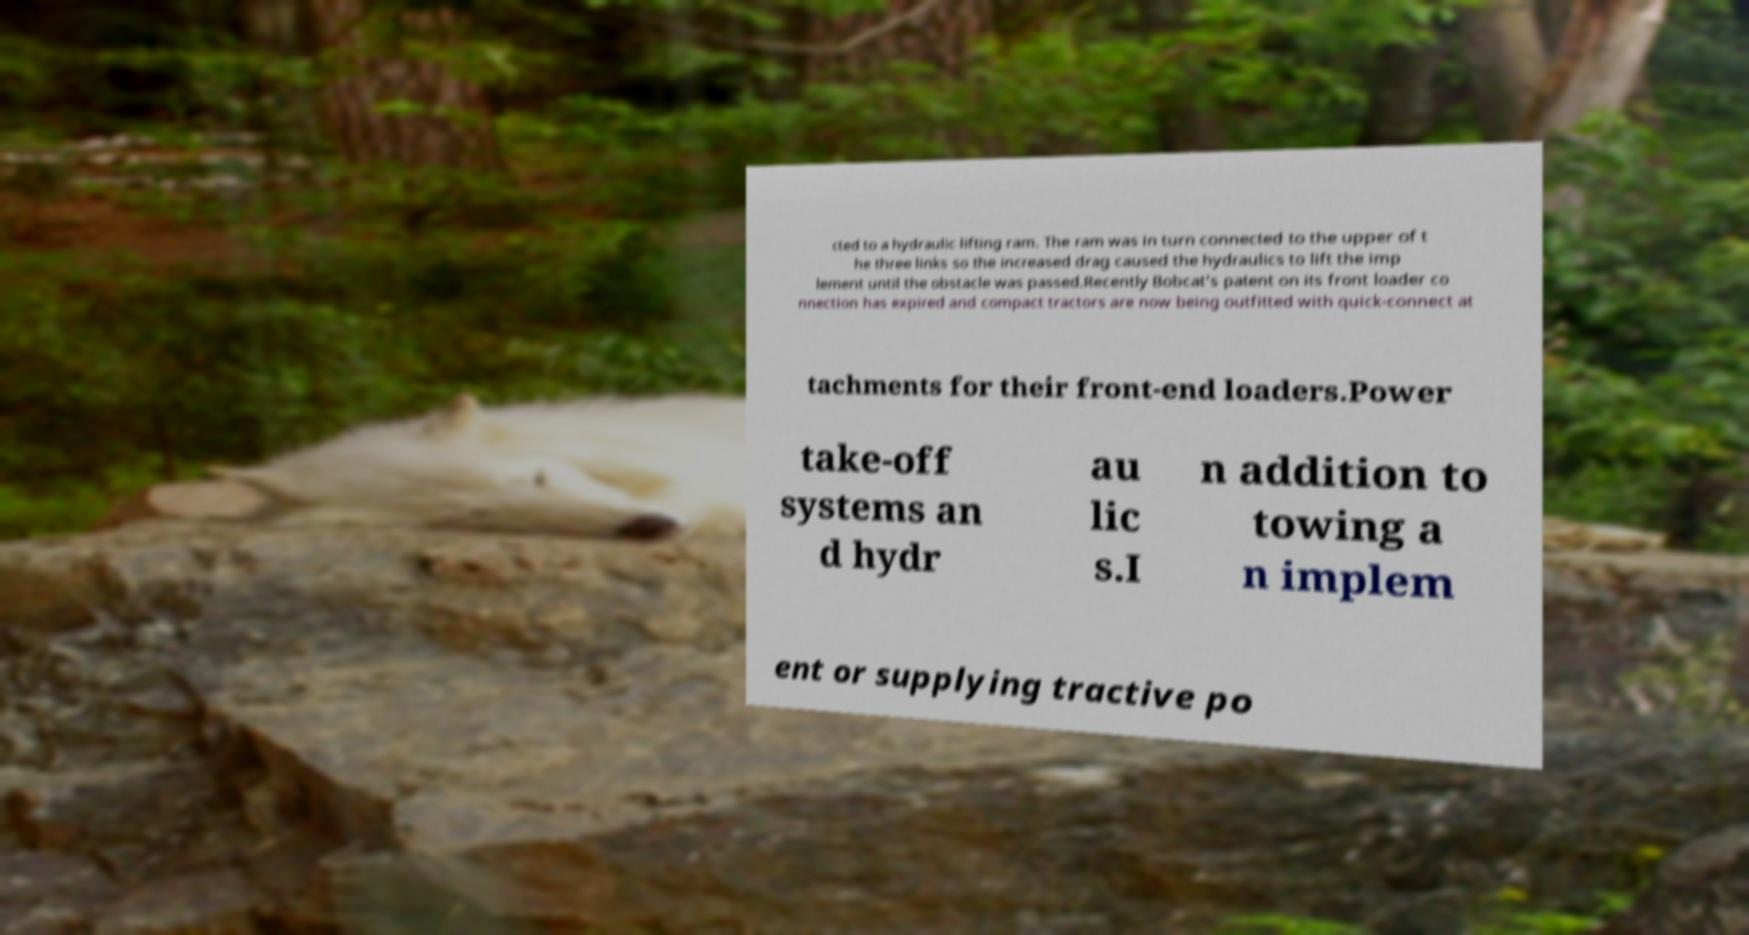Could you extract and type out the text from this image? cted to a hydraulic lifting ram. The ram was in turn connected to the upper of t he three links so the increased drag caused the hydraulics to lift the imp lement until the obstacle was passed.Recently Bobcat's patent on its front loader co nnection has expired and compact tractors are now being outfitted with quick-connect at tachments for their front-end loaders.Power take-off systems an d hydr au lic s.I n addition to towing a n implem ent or supplying tractive po 